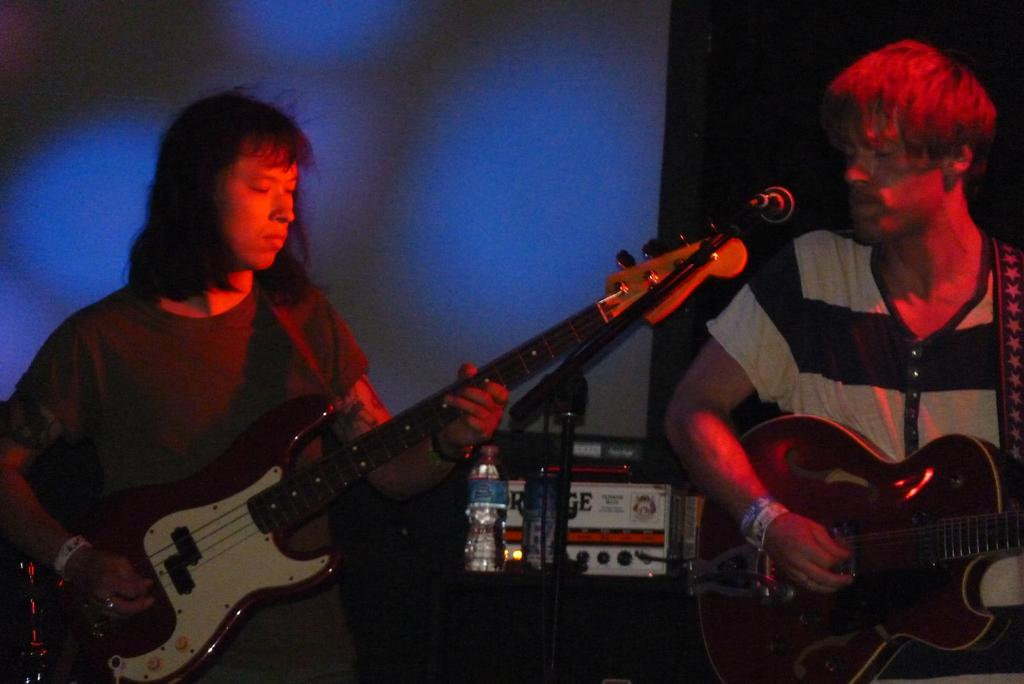How many people are in the image? There are two persons in the image. What are the persons holding in their hands? Each person is holding a guitar in their hands. What type of skate is being used by one of the persons in the image? There is no skate present in the image; both persons are holding guitars. Can you see the moon in the image? The moon is not visible in the image; it only features two persons holding guitars. 